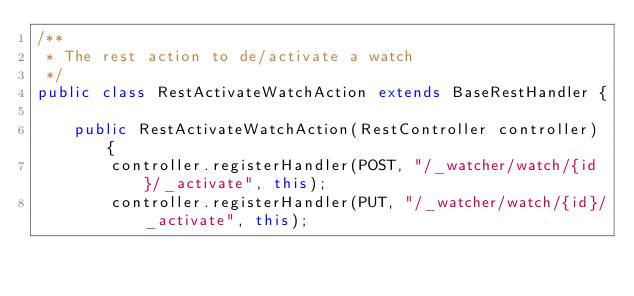Convert code to text. <code><loc_0><loc_0><loc_500><loc_500><_Java_>/**
 * The rest action to de/activate a watch
 */
public class RestActivateWatchAction extends BaseRestHandler {

    public RestActivateWatchAction(RestController controller) {
        controller.registerHandler(POST, "/_watcher/watch/{id}/_activate", this);
        controller.registerHandler(PUT, "/_watcher/watch/{id}/_activate", this);
</code> 